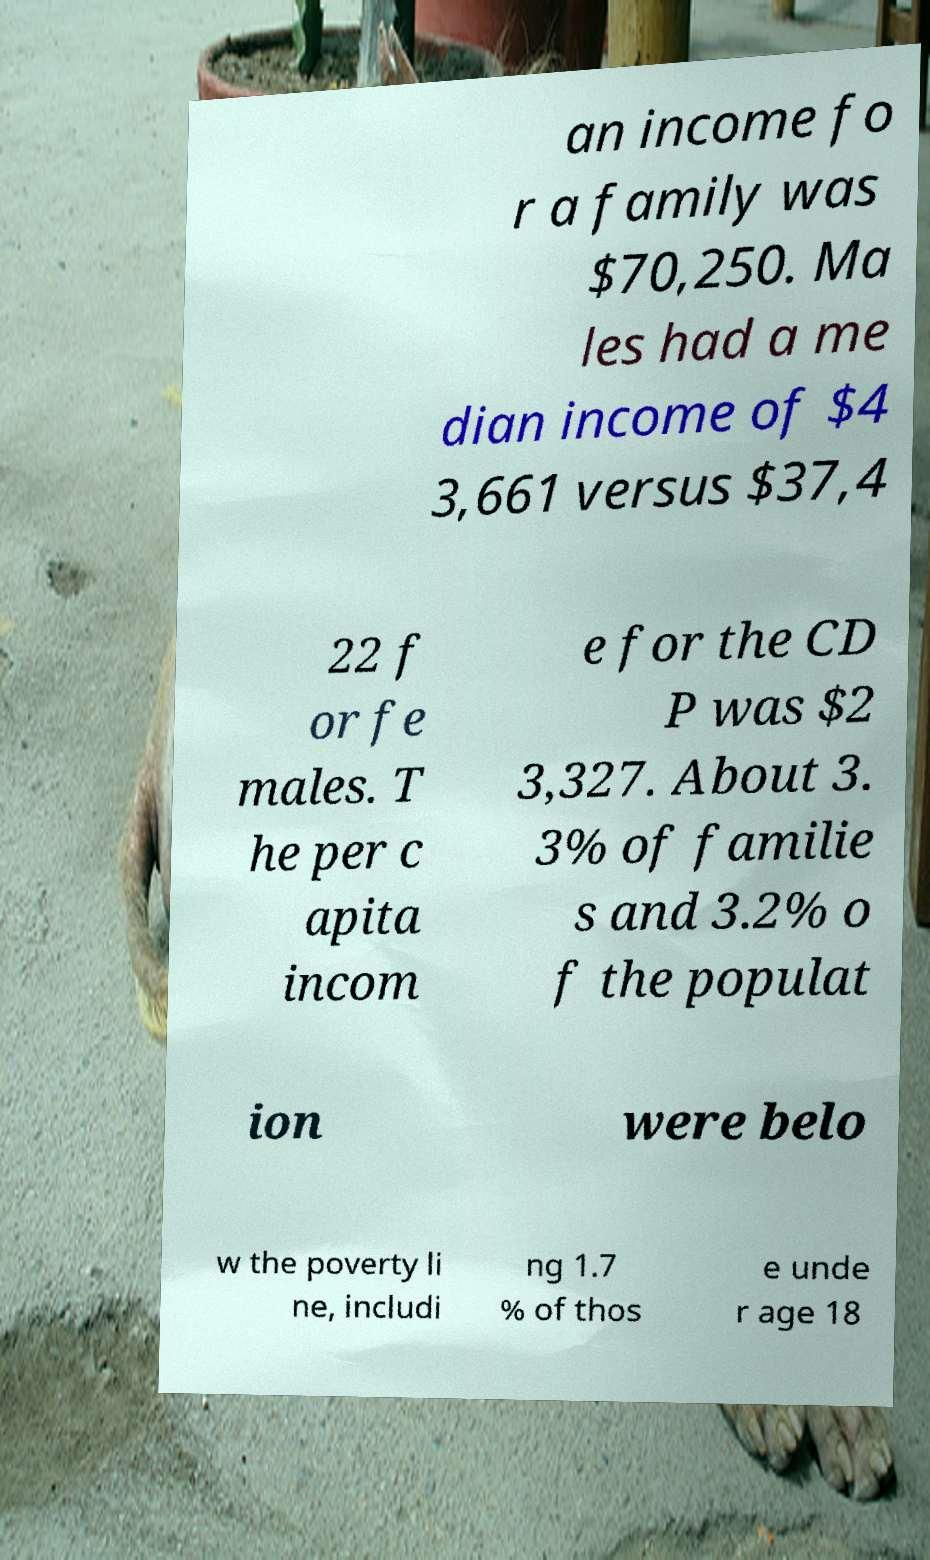Could you assist in decoding the text presented in this image and type it out clearly? an income fo r a family was $70,250. Ma les had a me dian income of $4 3,661 versus $37,4 22 f or fe males. T he per c apita incom e for the CD P was $2 3,327. About 3. 3% of familie s and 3.2% o f the populat ion were belo w the poverty li ne, includi ng 1.7 % of thos e unde r age 18 